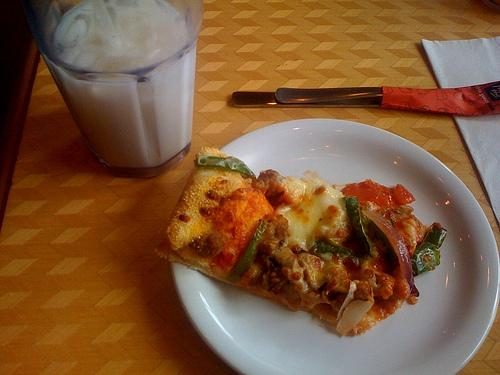How has this food been prepared for serving? sliced 